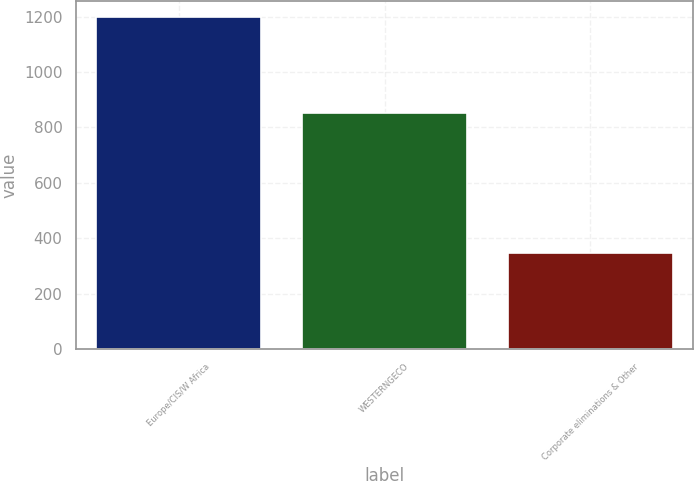<chart> <loc_0><loc_0><loc_500><loc_500><bar_chart><fcel>Europe/CIS/W Africa<fcel>WESTERNGECO<fcel>Corporate eliminations & Other<nl><fcel>1197<fcel>853<fcel>346<nl></chart> 